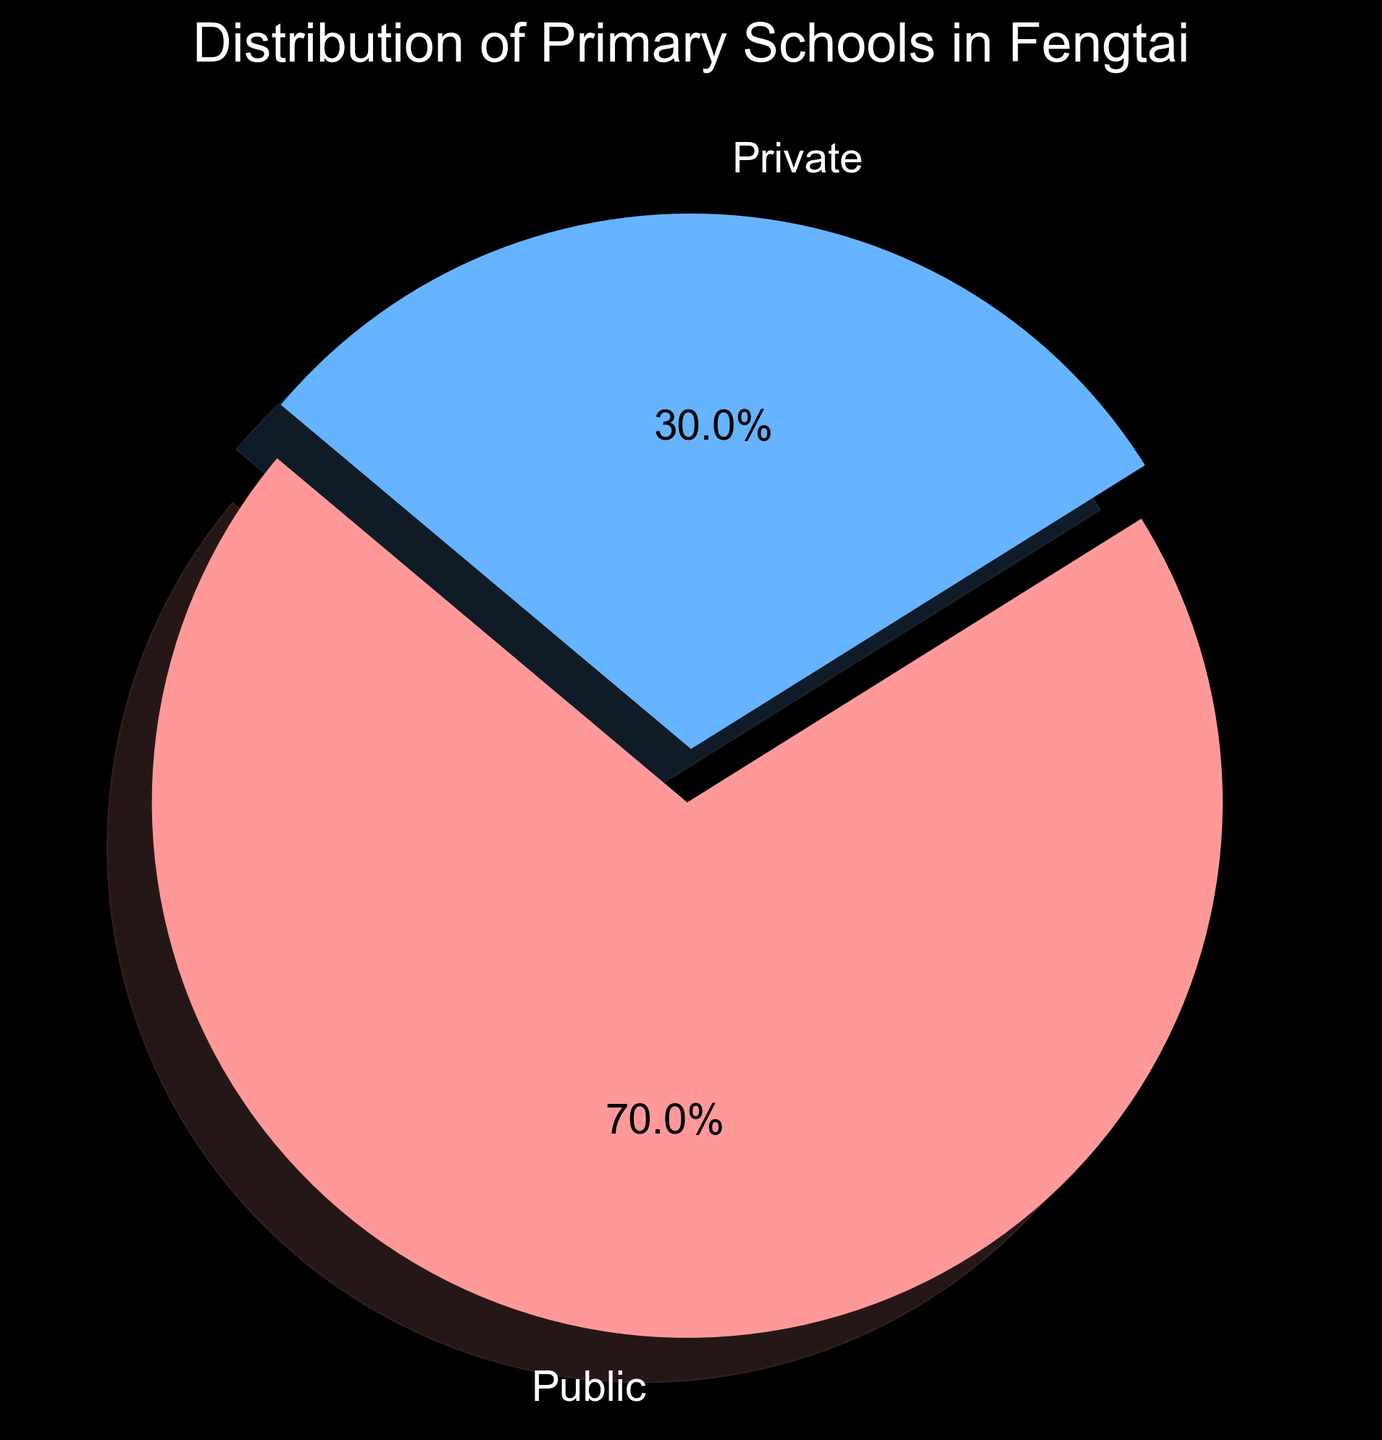Which type of primary school is more common in Fengtai? The pie chart shows two types of schools: Public and Private. The section of the chart for Public schools is larger compared to that for Private schools.
Answer: Public What percentage of primary schools in Fengtai are private? The pie chart labels indicate the percentage distribution of the schools. The label for Private schools shows "30.0%".
Answer: 30.0% Which type of school has the larger share visually represented in the pie chart? The pie chart’s larger section corresponds to Public schools.
Answer: Public How many public primary schools are there in Fengtai? The figure's legend or labels specify the number of schools. For Public schools, the number is given as 35.
Answer: 35 What is the difference in the number of schools between public and private primary schools in Fengtai? The numbers of Public and Private schools are given as 35 and 15, respectively. The difference is 35 - 15.
Answer: 20 What proportion of the total primary schools in Fengtai is public? The percentage on the pie chart for Public schools is shown as 70.0%.
Answer: 70.0% How many schools are there in total? Add the number of Public and Private schools from the text labels. This calculation is 35 (Public) + 15 (Private).
Answer: 50 What's the ratio of public to private primary schools in Fengtai? The number of Public schools is 35, and the number of Private schools is 15. The ratio is 35:15, which simplifies to 7:3.
Answer: 7:3 If Nanjiao and Beifang areas each have half of the public primary schools, how many public schools are there in each area? Total Public primary schools are 35. Half of 35 is 35 / 2 = 17.5.
Answer: 17.5 How much larger is the percentage of public primary schools compared to private primary schools in Fengtai? The percentage for Public is 70.0%, and for Private, it is 30.0%. The difference is 70.0% - 30.0%.
Answer: 40.0% 